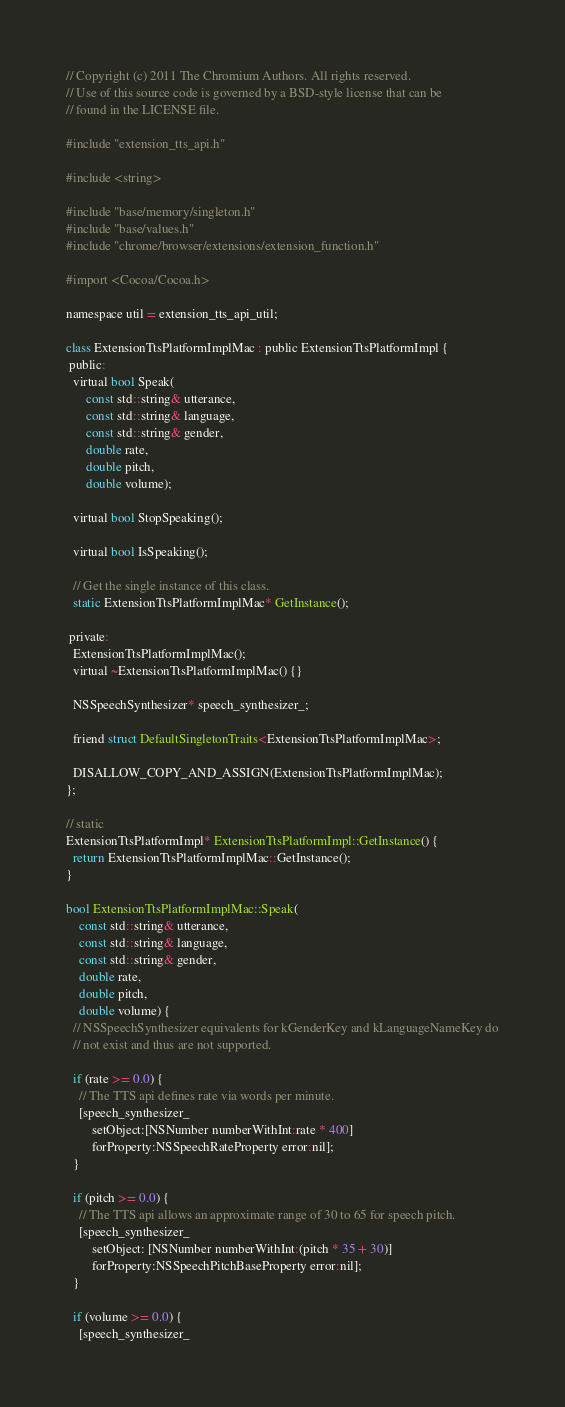<code> <loc_0><loc_0><loc_500><loc_500><_ObjectiveC_>// Copyright (c) 2011 The Chromium Authors. All rights reserved.
// Use of this source code is governed by a BSD-style license that can be
// found in the LICENSE file.

#include "extension_tts_api.h"

#include <string>

#include "base/memory/singleton.h"
#include "base/values.h"
#include "chrome/browser/extensions/extension_function.h"

#import <Cocoa/Cocoa.h>

namespace util = extension_tts_api_util;

class ExtensionTtsPlatformImplMac : public ExtensionTtsPlatformImpl {
 public:
  virtual bool Speak(
      const std::string& utterance,
      const std::string& language,
      const std::string& gender,
      double rate,
      double pitch,
      double volume);

  virtual bool StopSpeaking();

  virtual bool IsSpeaking();

  // Get the single instance of this class.
  static ExtensionTtsPlatformImplMac* GetInstance();

 private:
  ExtensionTtsPlatformImplMac();
  virtual ~ExtensionTtsPlatformImplMac() {}

  NSSpeechSynthesizer* speech_synthesizer_;

  friend struct DefaultSingletonTraits<ExtensionTtsPlatformImplMac>;

  DISALLOW_COPY_AND_ASSIGN(ExtensionTtsPlatformImplMac);
};

// static
ExtensionTtsPlatformImpl* ExtensionTtsPlatformImpl::GetInstance() {
  return ExtensionTtsPlatformImplMac::GetInstance();
}

bool ExtensionTtsPlatformImplMac::Speak(
    const std::string& utterance,
    const std::string& language,
    const std::string& gender,
    double rate,
    double pitch,
    double volume) {
  // NSSpeechSynthesizer equivalents for kGenderKey and kLanguageNameKey do
  // not exist and thus are not supported.

  if (rate >= 0.0) {
    // The TTS api defines rate via words per minute.
    [speech_synthesizer_
        setObject:[NSNumber numberWithInt:rate * 400]
        forProperty:NSSpeechRateProperty error:nil];
  }

  if (pitch >= 0.0) {
    // The TTS api allows an approximate range of 30 to 65 for speech pitch.
    [speech_synthesizer_
        setObject: [NSNumber numberWithInt:(pitch * 35 + 30)]
        forProperty:NSSpeechPitchBaseProperty error:nil];
  }

  if (volume >= 0.0) {
    [speech_synthesizer_</code> 